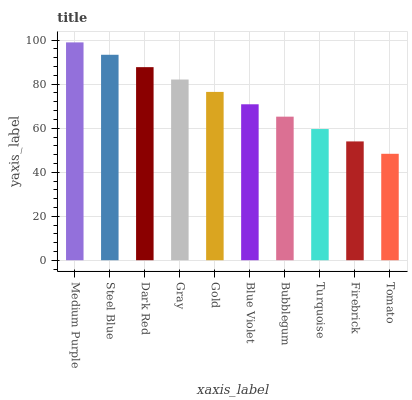Is Steel Blue the minimum?
Answer yes or no. No. Is Steel Blue the maximum?
Answer yes or no. No. Is Medium Purple greater than Steel Blue?
Answer yes or no. Yes. Is Steel Blue less than Medium Purple?
Answer yes or no. Yes. Is Steel Blue greater than Medium Purple?
Answer yes or no. No. Is Medium Purple less than Steel Blue?
Answer yes or no. No. Is Gold the high median?
Answer yes or no. Yes. Is Blue Violet the low median?
Answer yes or no. Yes. Is Firebrick the high median?
Answer yes or no. No. Is Bubblegum the low median?
Answer yes or no. No. 